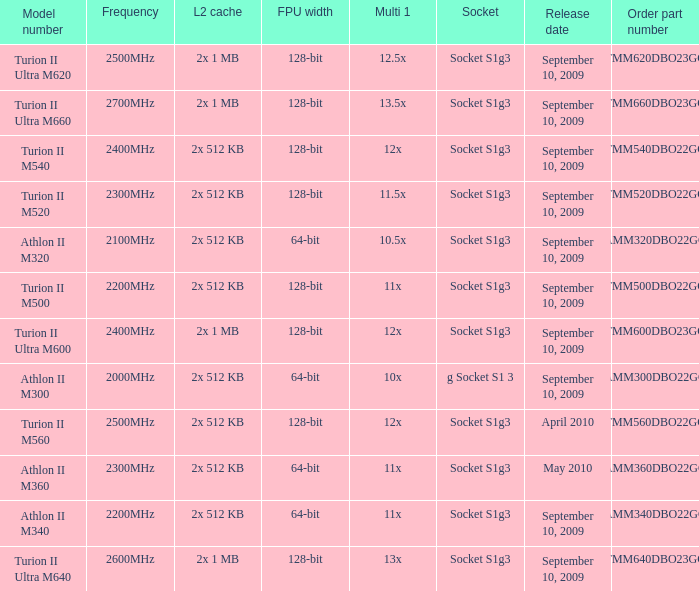What is the socket with an order part number of amm300dbo22gq and a September 10, 2009 release date? G socket s1 3. 